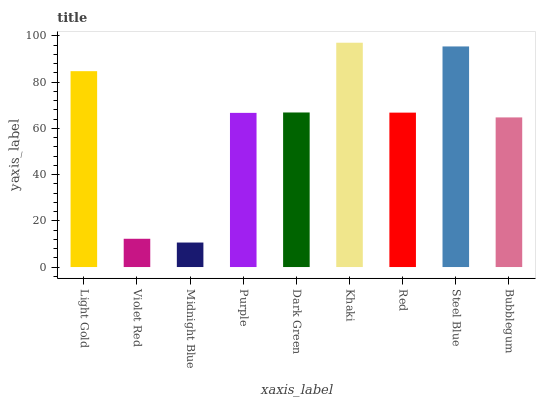Is Midnight Blue the minimum?
Answer yes or no. Yes. Is Khaki the maximum?
Answer yes or no. Yes. Is Violet Red the minimum?
Answer yes or no. No. Is Violet Red the maximum?
Answer yes or no. No. Is Light Gold greater than Violet Red?
Answer yes or no. Yes. Is Violet Red less than Light Gold?
Answer yes or no. Yes. Is Violet Red greater than Light Gold?
Answer yes or no. No. Is Light Gold less than Violet Red?
Answer yes or no. No. Is Red the high median?
Answer yes or no. Yes. Is Red the low median?
Answer yes or no. Yes. Is Khaki the high median?
Answer yes or no. No. Is Steel Blue the low median?
Answer yes or no. No. 